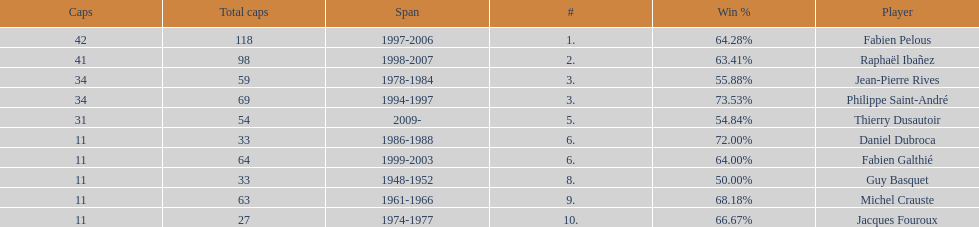How long did fabien pelous serve as captain in the french national rugby team? 9 years. 